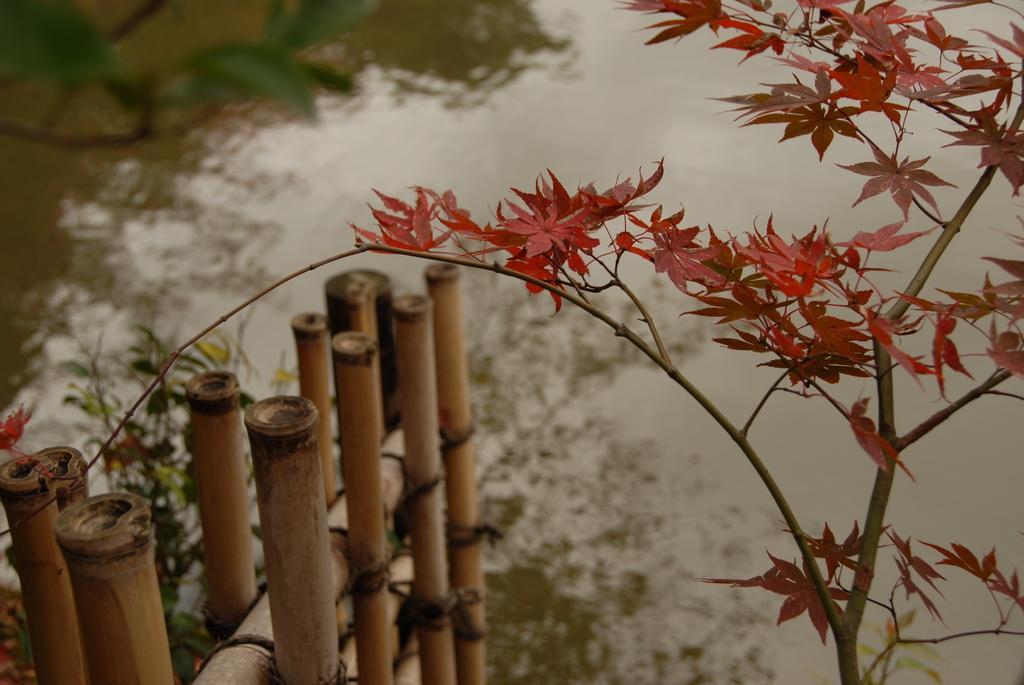In one or two sentences, can you explain what this image depicts? In the left bottom of the picture, we see the wooden fence. On the right side, we see a tree which has the red color leaves. In the background, we see water and this water might be in the pond. We see the reflections of the trees in the water. 